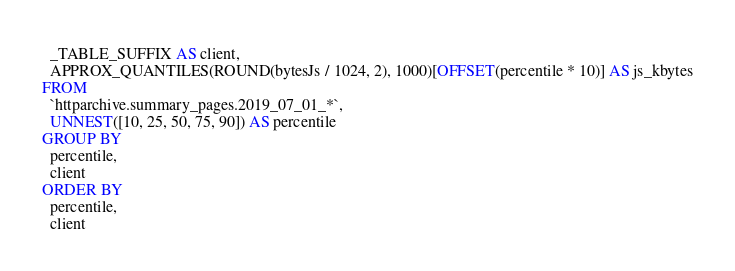<code> <loc_0><loc_0><loc_500><loc_500><_SQL_>  _TABLE_SUFFIX AS client,
  APPROX_QUANTILES(ROUND(bytesJs / 1024, 2), 1000)[OFFSET(percentile * 10)] AS js_kbytes
FROM
  `httparchive.summary_pages.2019_07_01_*`,
  UNNEST([10, 25, 50, 75, 90]) AS percentile
GROUP BY
  percentile,
  client
ORDER BY
  percentile,
  client
</code> 